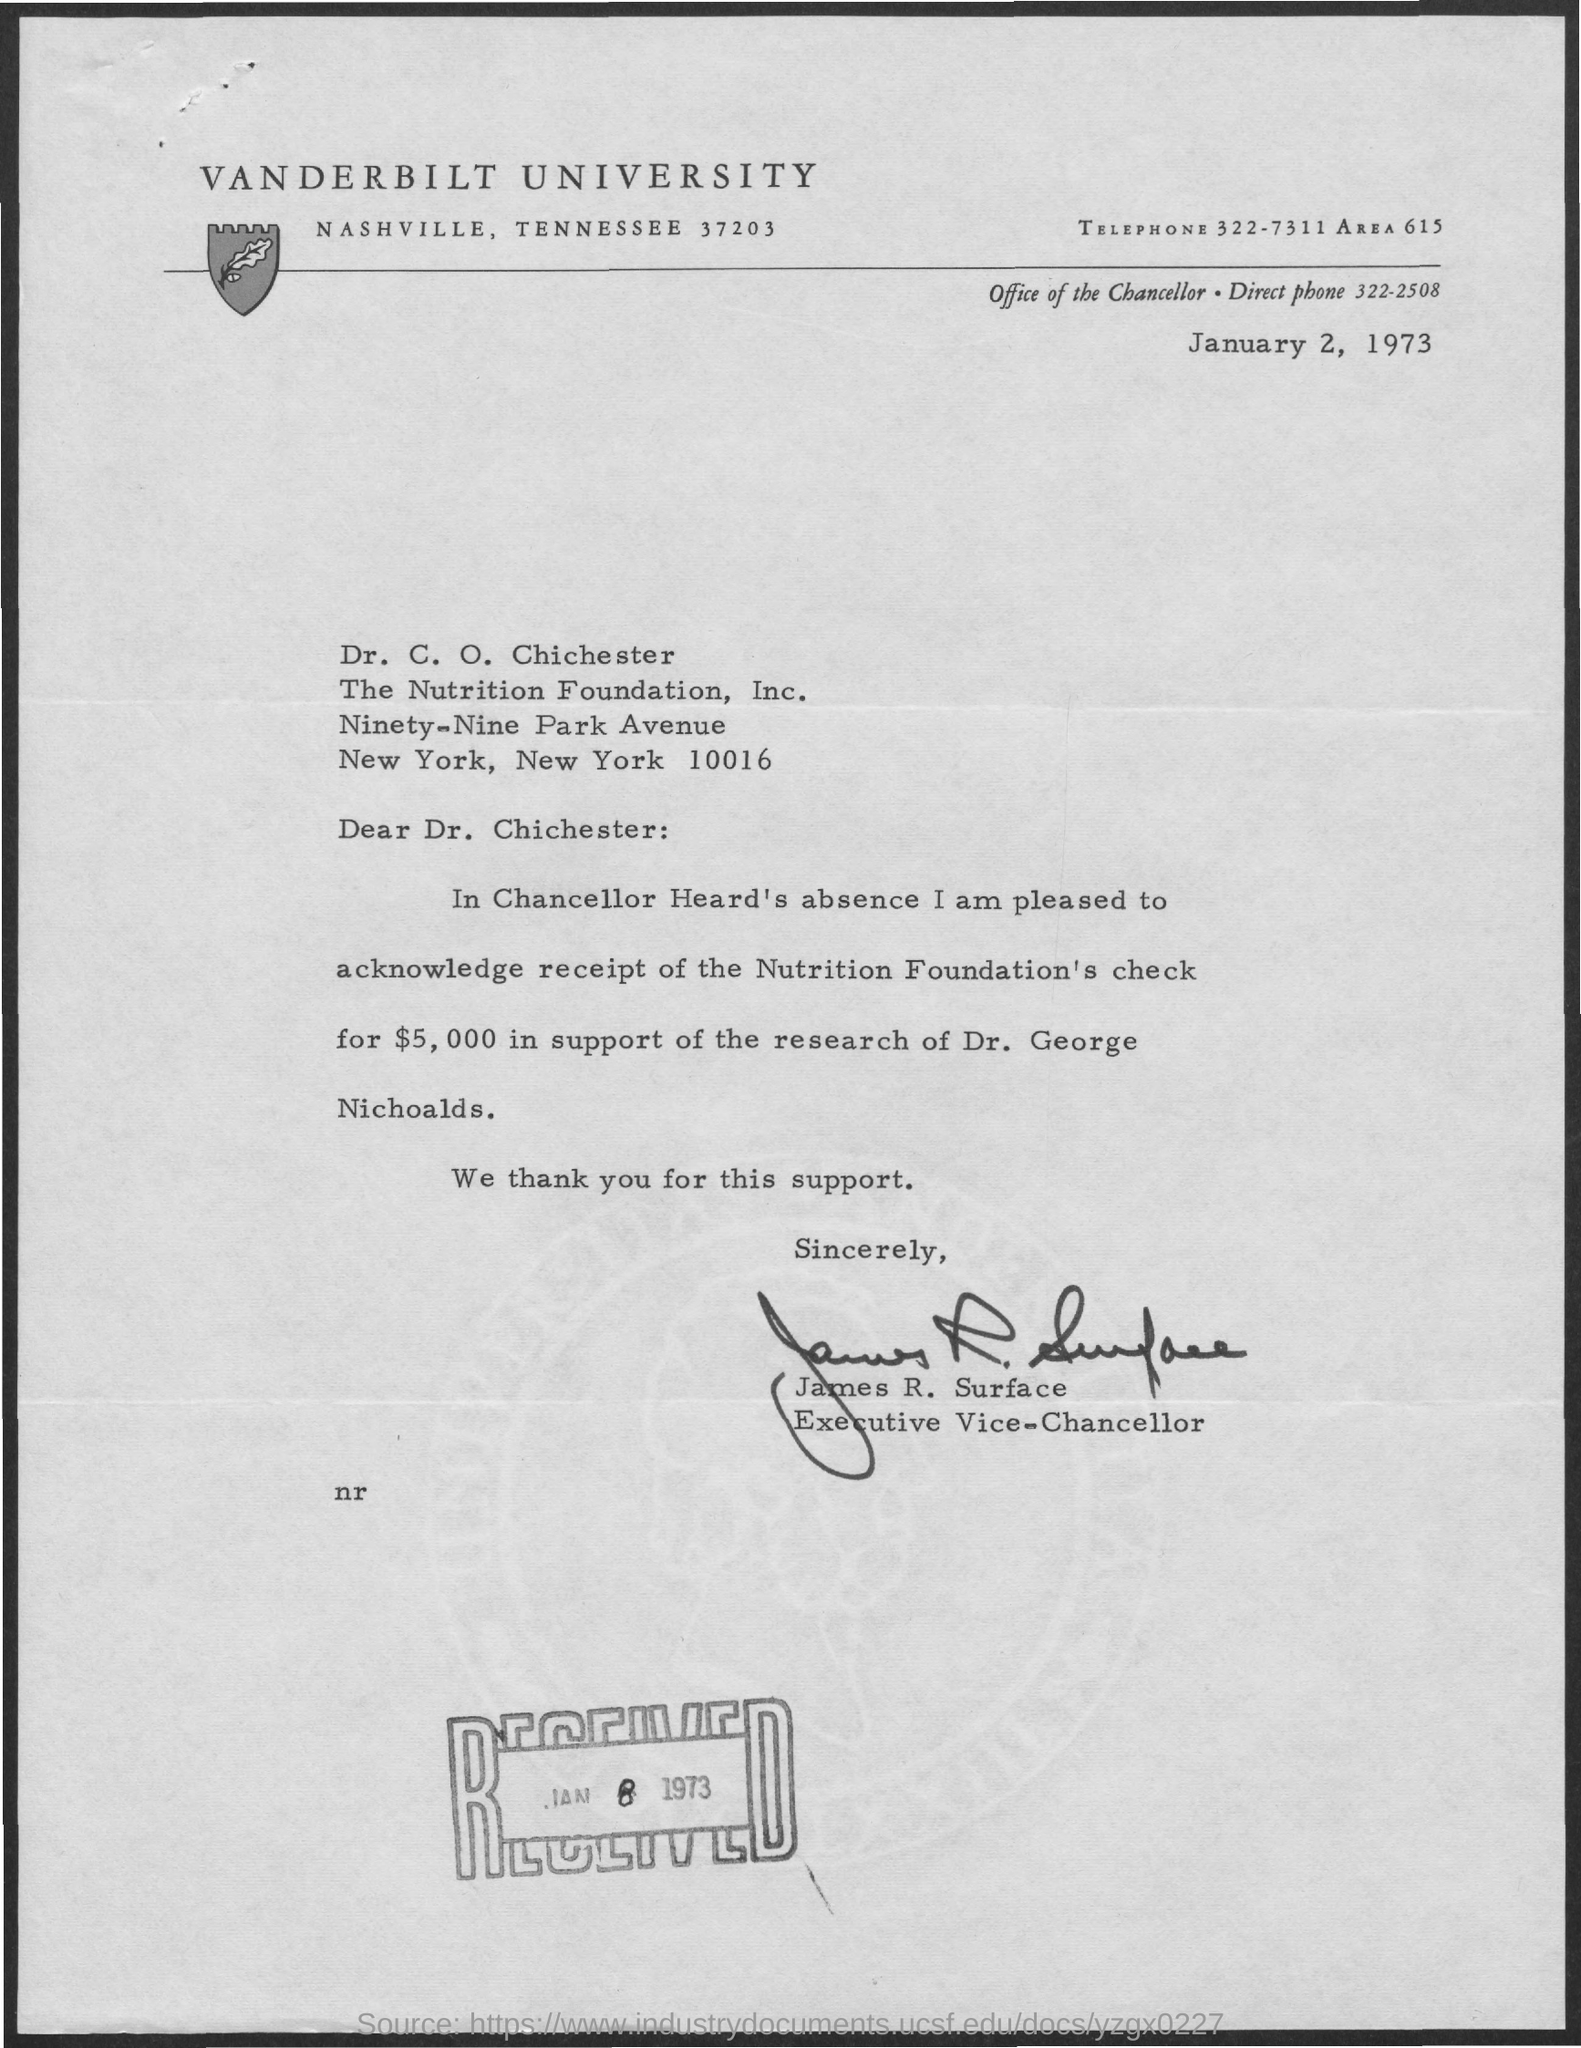List a handful of essential elements in this visual. The date of received is January 8, 1973. James R. Surface is the executive vice-chancellor of the university. The check amount is $5,000. Vanderbilt University is the name of the university. The office of the chancellor can be reached by dialing 322-2508. 